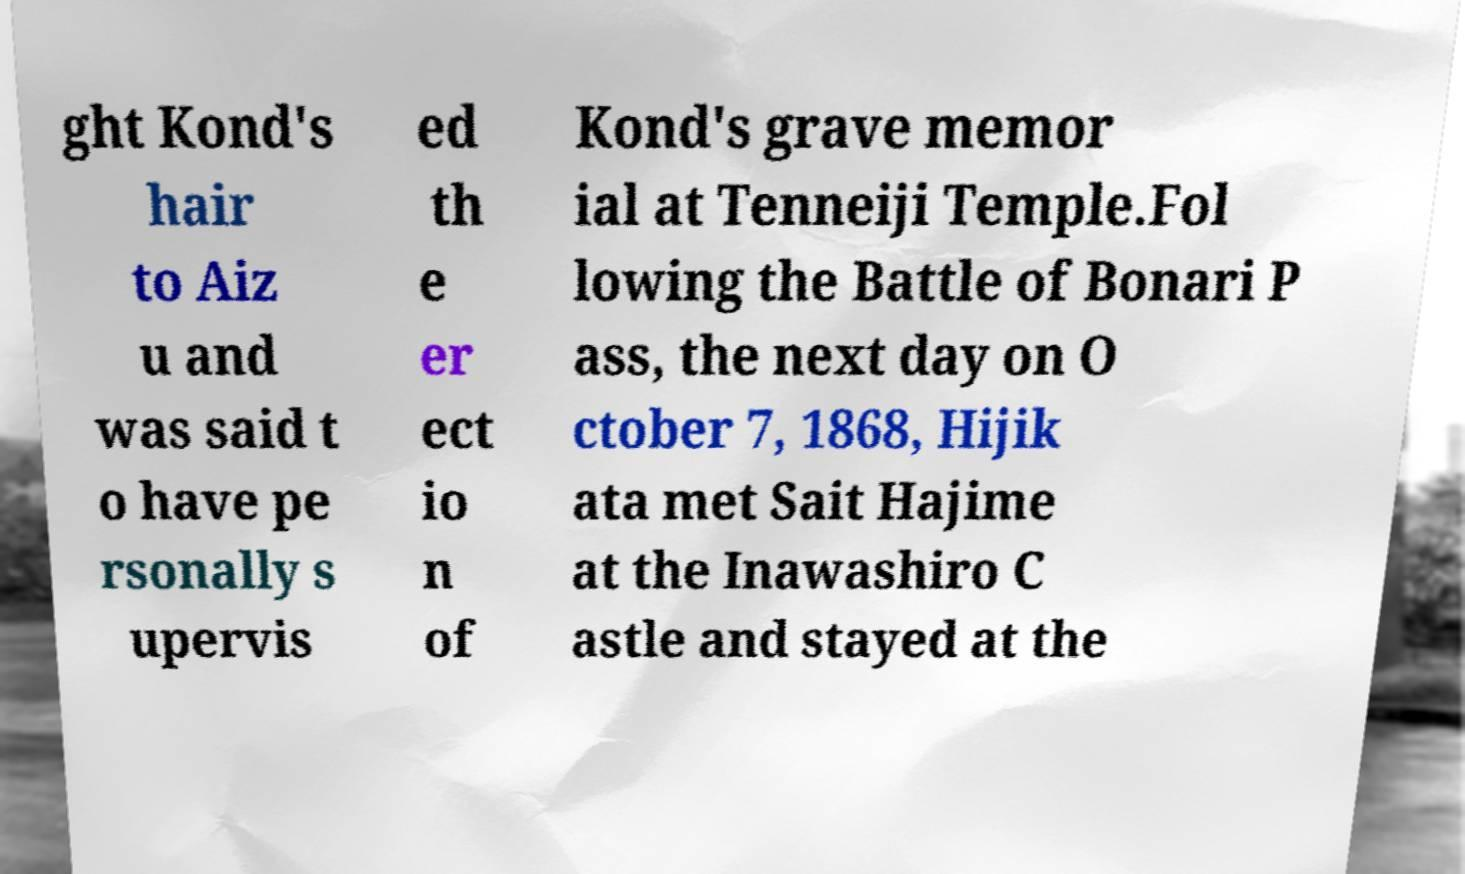Could you assist in decoding the text presented in this image and type it out clearly? ght Kond's hair to Aiz u and was said t o have pe rsonally s upervis ed th e er ect io n of Kond's grave memor ial at Tenneiji Temple.Fol lowing the Battle of Bonari P ass, the next day on O ctober 7, 1868, Hijik ata met Sait Hajime at the Inawashiro C astle and stayed at the 